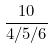<formula> <loc_0><loc_0><loc_500><loc_500>\frac { 1 0 } { 4 / 5 / 6 }</formula> 